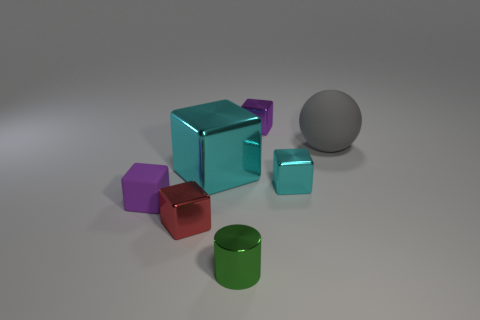Subtract all small red blocks. How many blocks are left? 4 Subtract all spheres. How many objects are left? 6 Add 1 small cyan matte cylinders. How many objects exist? 8 Subtract all purple cubes. How many cubes are left? 3 Subtract all red cubes. Subtract all gray balls. How many cubes are left? 4 Subtract all purple cubes. How many yellow spheres are left? 0 Subtract all large brown blocks. Subtract all small green metal cylinders. How many objects are left? 6 Add 5 tiny red metallic objects. How many tiny red metallic objects are left? 6 Add 6 cyan metallic blocks. How many cyan metallic blocks exist? 8 Subtract 0 green blocks. How many objects are left? 7 